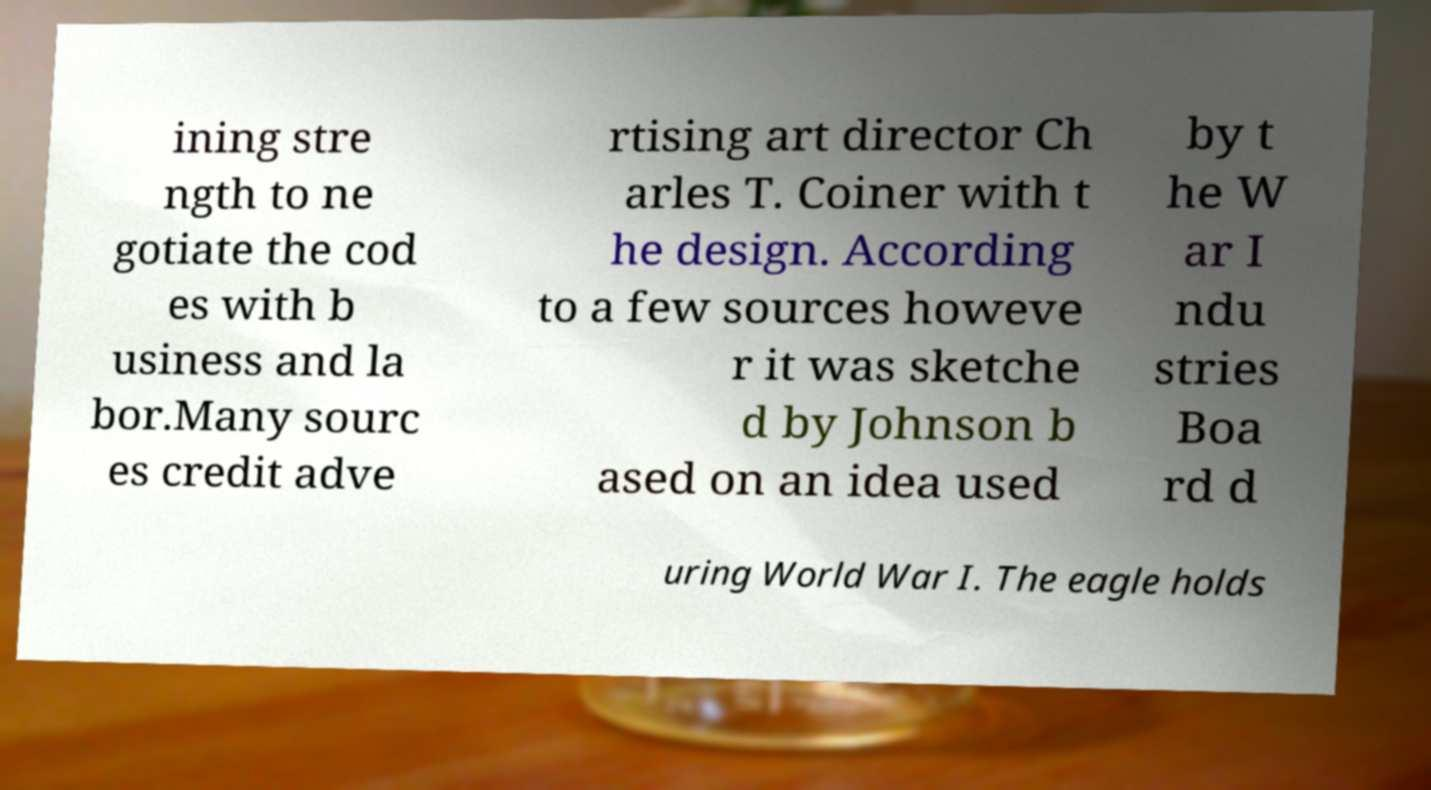I need the written content from this picture converted into text. Can you do that? ining stre ngth to ne gotiate the cod es with b usiness and la bor.Many sourc es credit adve rtising art director Ch arles T. Coiner with t he design. According to a few sources howeve r it was sketche d by Johnson b ased on an idea used by t he W ar I ndu stries Boa rd d uring World War I. The eagle holds 